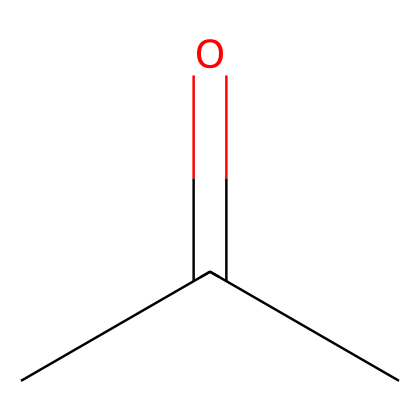What is the molecular formula of this chemical? The SMILES representation CC(=O)C indicates that the compound contains three carbon atoms (C), six hydrogen atoms (H), and one oxygen atom (O), combining to form the molecular formula C3H6O.
Answer: C3H6O How many carbon atoms are in this structure? Analyzing the SMILES notation CC(=O)C reveals three carbon atoms (C) are present: two are in the CC part and one in the C next to the carbonyl group (C=O).
Answer: 3 What type of functional group is present in this molecule? The presence of the carbonyl group (C=O) in the structure CC(=O)C indicates that this molecule has a ketone functional group, as it is attached to two carbon atoms.
Answer: ketone Does this compound have a double bond? The structural formula CC(=O)C shows a carbon atom double-bonded to an oxygen atom (C=O), which means it contains at least one double bond within its structure.
Answer: yes What is the common use of this chemical in electronics? Acetone is commonly used in electronics as a solvent and an adhesive, especially in repairs and cleaning applications due to its effectiveness in dissolving various substances and removing residues.
Answer: solvent Is this compound saturated or unsaturated? The structure CC(=O)C contains a double bond (C=O), indicating that it has unsaturation in terms of its carbon structure. Therefore, it is classified as an unsaturated compound due to the presence of the double bond.
Answer: unsaturated 